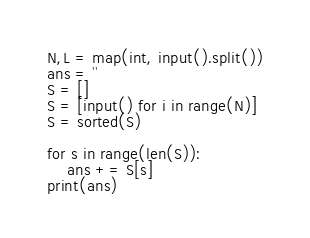Convert code to text. <code><loc_0><loc_0><loc_500><loc_500><_Python_>N,L = map(int, input().split())
ans = ''
S = []
S = [input() for i in range(N)]
S = sorted(S)

for s in range(len(S)):
    ans += S[s]
print(ans)
</code> 